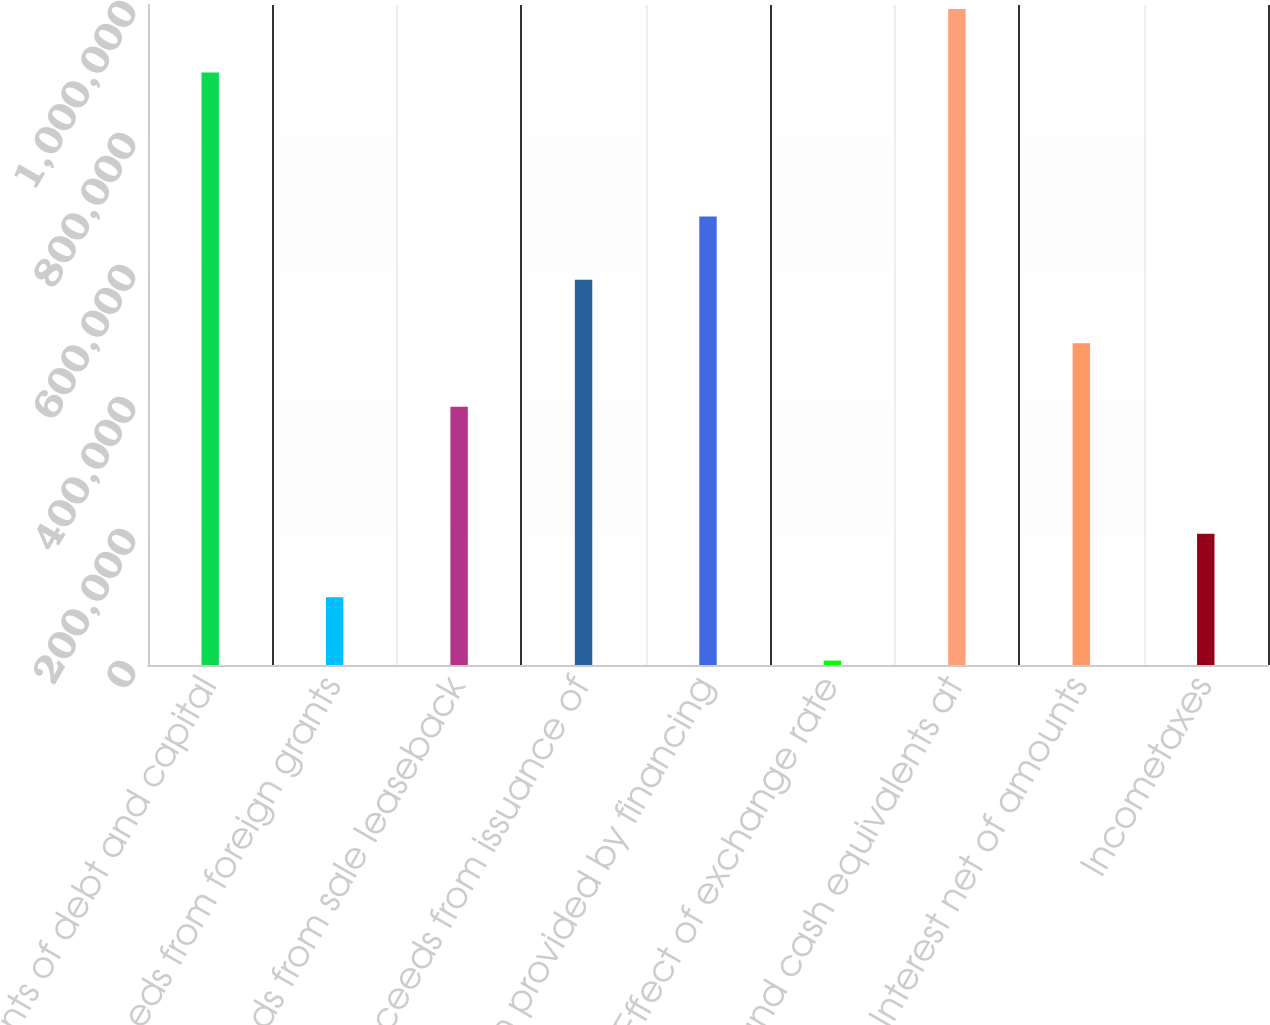Convert chart. <chart><loc_0><loc_0><loc_500><loc_500><bar_chart><fcel>Repayments of debt and capital<fcel>Proceeds from foreign grants<fcel>Proceeds from sale leaseback<fcel>Proceeds from issuance of<fcel>Net cash provided by financing<fcel>Effect of exchange rate<fcel>Cash and cash equivalents at<fcel>Interest net of amounts<fcel>Incometaxes<nl><fcel>897619<fcel>102810<fcel>391267<fcel>583573<fcel>679725<fcel>6657<fcel>993772<fcel>487420<fcel>198962<nl></chart> 